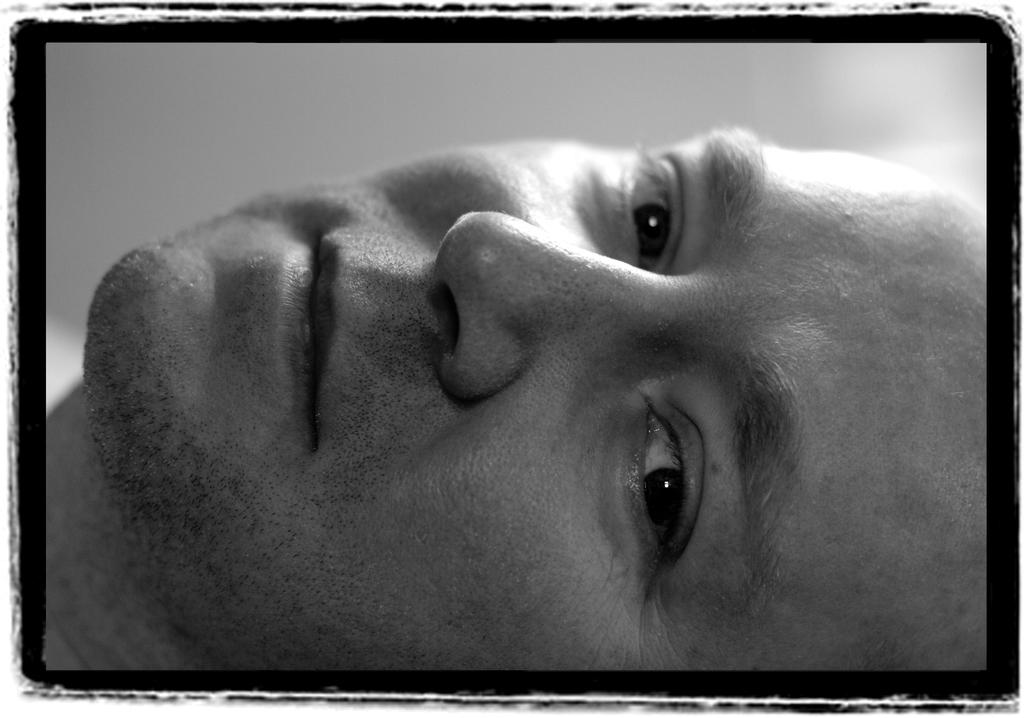What is the main subject of the image? There is a man's face in the image. Can you describe the background of the image? The background of the image is blurry. What type of border is present in the image? There is a black color border in the image. What sound does the chance make in the image? There is no mention of a chance or any sound-making objects in the image. 